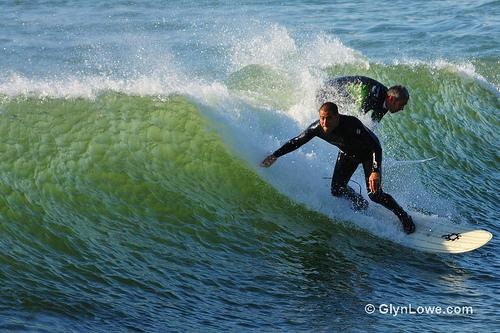Briefly describe the surfboard in the image. It is a white surfboard with a black design on top and black shoes on it. What is the main color of the ocean in the image? The main color of the ocean is blue. What is the main focus of the product advertisement task for this image? The main focus is to promote surfing gear and equipment, like surfboards and wetsuits. Describe the appearance of one of the men involved in the main activity in the image. The man is wearing a black wet suit and has short hair, and he is balancing on a surfboard. Which task would require you to identify important phrases written in the image? The referential expression grounding task. Mention an activity taking place in the image involving two people. Two men are surfing side by side on the same wave. What interesting aspect of the ocean wave can be noticed in this picture? The green underside of the wave is lit up by sunlight. Identify an item of clothing worn by one of the subjects in the image that can be used for a visual entailment task. The black wet suit for the surfer could be used for the task. In a visual entailment task, what relationship might be inferred between the surfers and the ocean wave? The surfers are riding the ocean wave and utilizing its energy. List at least three different objects present in the image that can be used for a multi-choice VQA task. White surfboard, black wet suit, and green ocean water with ripples. 